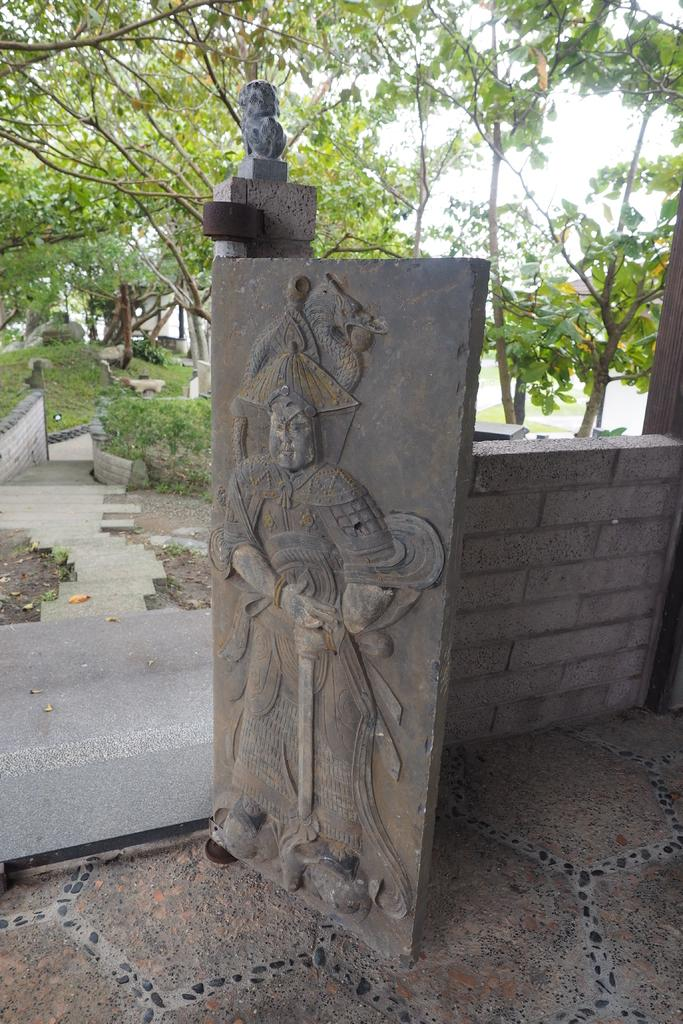What is depicted on the stone in the image? There are carvings on a stone in the image. What is located on the right side of the image? There is a wall on the right side of the image. What type of natural environment is visible in the background of the image? There are trees in the background of the image. Can you tell me how many jellyfish are swimming in the image? There are no jellyfish present in the image; it features carvings on a stone, a wall, and trees in the background. What is the starting point of the story depicted in the image? The image does not depict a story, so there is no starting point to identify. 